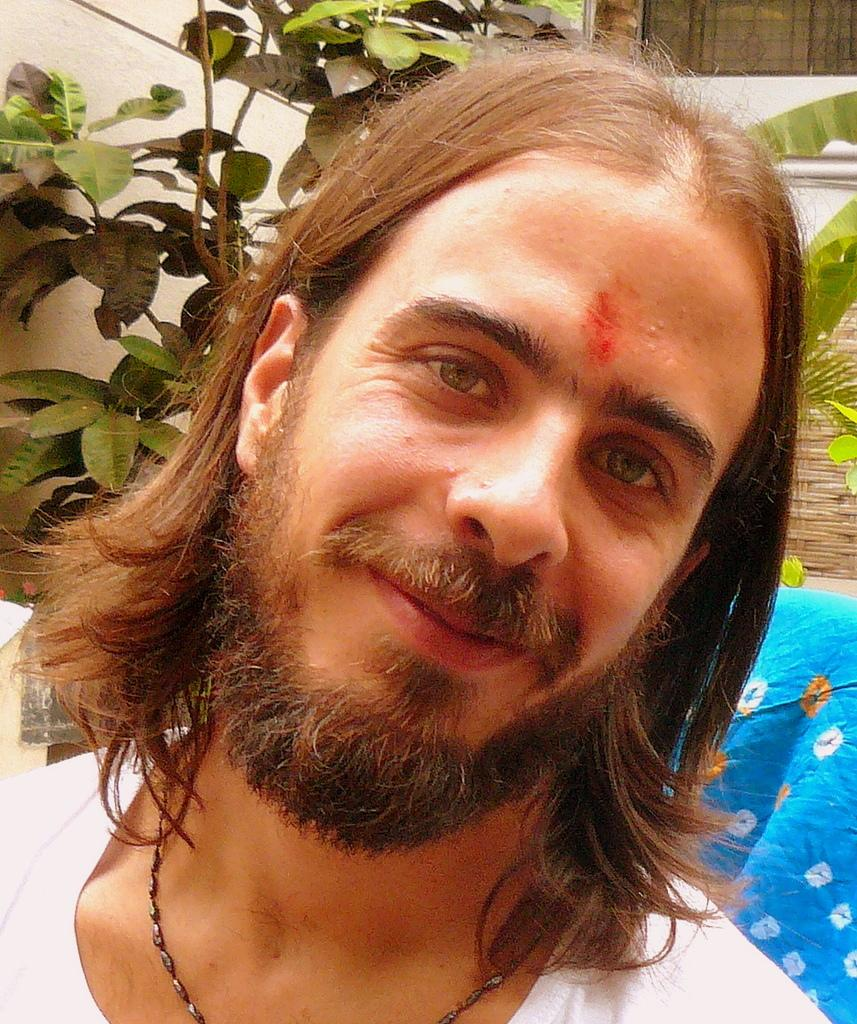Who is the main subject in the foreground of the image? There is a man in the foreground of the image. Can you describe the man's appearance? The man has short hair. What can be seen in the background of the image? Many leaves of a plant are visible behind the man. What type of thunder can be heard in the image? There is no sound present in the image, so it is not possible to determine if thunder can be heard. 